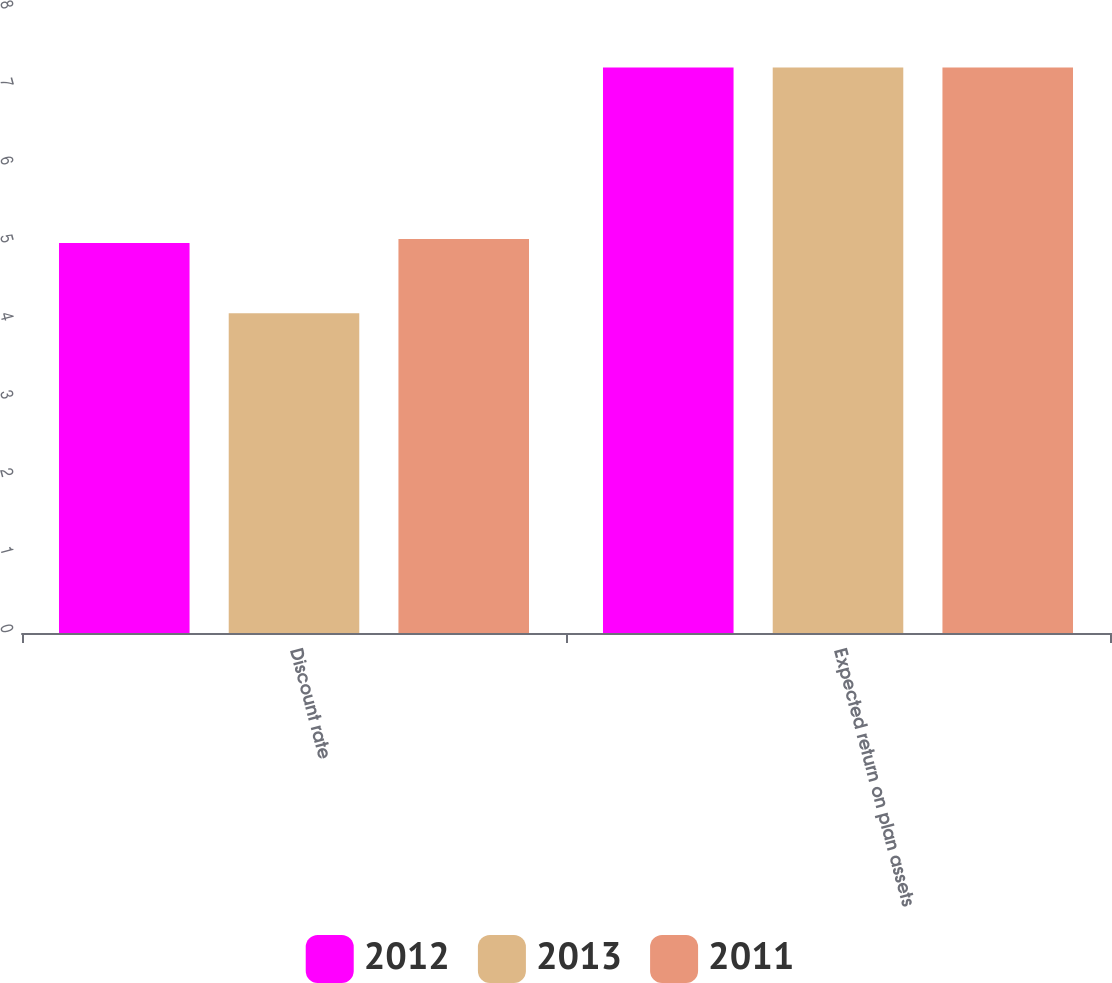Convert chart to OTSL. <chart><loc_0><loc_0><loc_500><loc_500><stacked_bar_chart><ecel><fcel>Discount rate<fcel>Expected return on plan assets<nl><fcel>2012<fcel>5<fcel>7.25<nl><fcel>2013<fcel>4.1<fcel>7.25<nl><fcel>2011<fcel>5.05<fcel>7.25<nl></chart> 